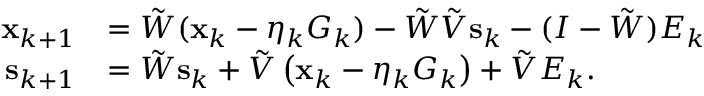Convert formula to latex. <formula><loc_0><loc_0><loc_500><loc_500>\begin{array} { r l } { x _ { k + 1 } } & { = \tilde { W } ( x _ { k } - \eta _ { k } G _ { k } ) - \tilde { W } \tilde { V } s _ { k } - ( I - \tilde { W } ) E _ { k } } \\ { s _ { k + 1 } } & { = \tilde { W } s _ { k } + \tilde { V } \left ( x _ { k } - \eta _ { k } G _ { k } \right ) + \tilde { V } E _ { k } . } \end{array}</formula> 